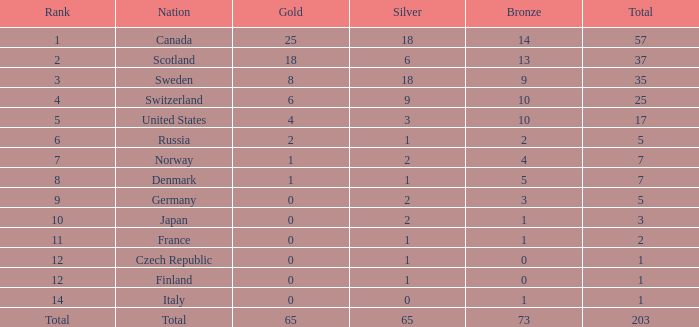What is the number of bronze medals when the total is greater than 1, more than 2 silver medals are won, and the rank is 2? 13.0. 